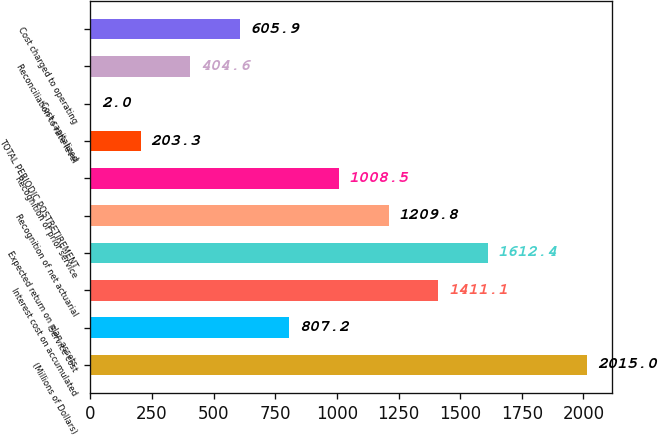Convert chart. <chart><loc_0><loc_0><loc_500><loc_500><bar_chart><fcel>(Millions of Dollars)<fcel>Service cost<fcel>Interest cost on accumulated<fcel>Expected return on plan assets<fcel>Recognition of net actuarial<fcel>Recognition of prior service<fcel>TOTAL PERIODIC POSTRETIREMENT<fcel>Cost capitalized<fcel>Reconciliation to rate level<fcel>Cost charged to operating<nl><fcel>2015<fcel>807.2<fcel>1411.1<fcel>1612.4<fcel>1209.8<fcel>1008.5<fcel>203.3<fcel>2<fcel>404.6<fcel>605.9<nl></chart> 